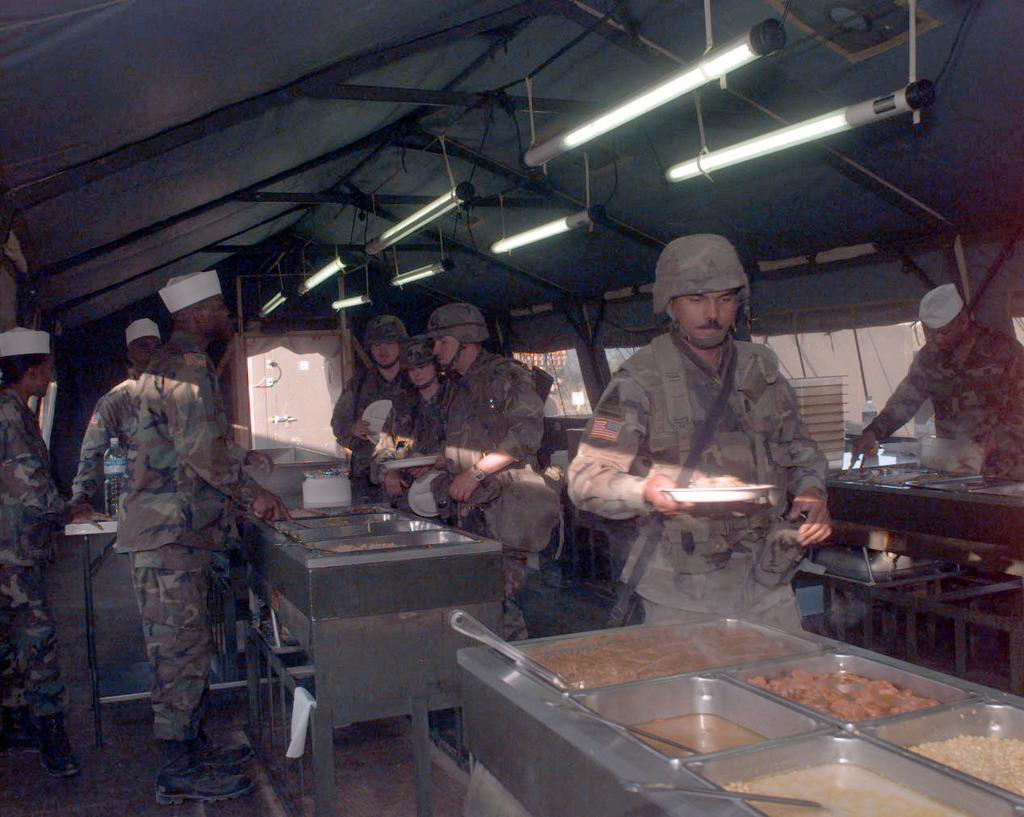How would you summarize this image in a sentence or two? In this picture we can see there are a group of people standing and some people are holding the plates and in between the people there are some food items in the bowls. Behind the people there is an object and at the top there are lights. On the left side of the people there is a bottle on the table. 